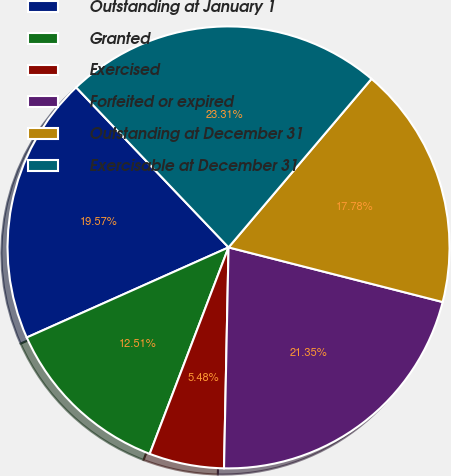Convert chart to OTSL. <chart><loc_0><loc_0><loc_500><loc_500><pie_chart><fcel>Outstanding at January 1<fcel>Granted<fcel>Exercised<fcel>Forfeited or expired<fcel>Outstanding at December 31<fcel>Exercisable at December 31<nl><fcel>19.57%<fcel>12.51%<fcel>5.48%<fcel>21.35%<fcel>17.78%<fcel>23.31%<nl></chart> 